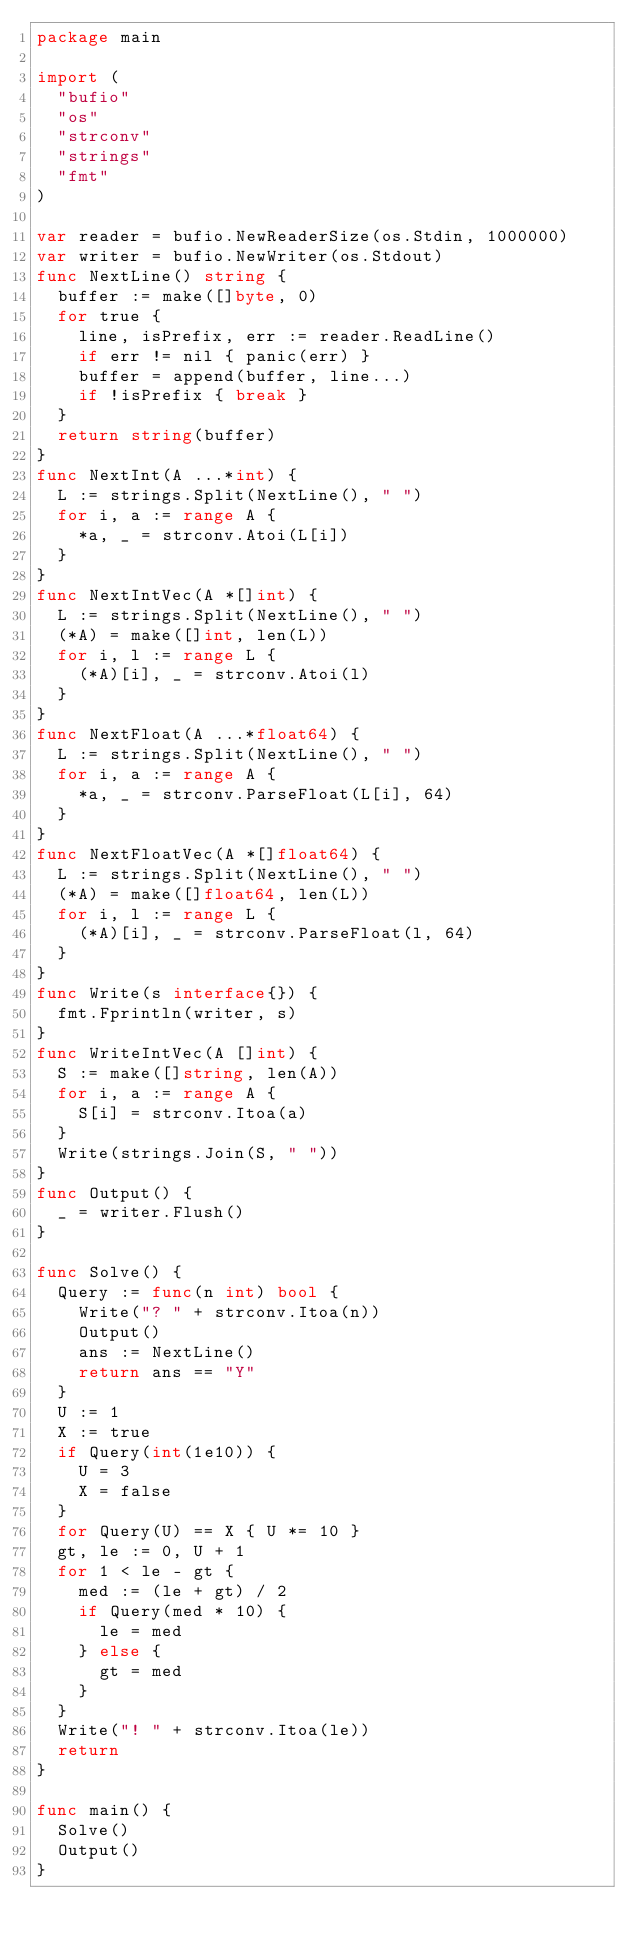<code> <loc_0><loc_0><loc_500><loc_500><_Go_>package main

import (
  "bufio"
  "os"
  "strconv"
  "strings"
  "fmt"
)

var reader = bufio.NewReaderSize(os.Stdin, 1000000)
var writer = bufio.NewWriter(os.Stdout)
func NextLine() string {
  buffer := make([]byte, 0)
  for true {
    line, isPrefix, err := reader.ReadLine()
    if err != nil { panic(err) }
    buffer = append(buffer, line...)
    if !isPrefix { break }
  }
  return string(buffer)
}
func NextInt(A ...*int) {
  L := strings.Split(NextLine(), " ")
  for i, a := range A {
    *a, _ = strconv.Atoi(L[i])
  }
}
func NextIntVec(A *[]int) {
  L := strings.Split(NextLine(), " ")
  (*A) = make([]int, len(L))
  for i, l := range L {
    (*A)[i], _ = strconv.Atoi(l)
  }
}
func NextFloat(A ...*float64) {
  L := strings.Split(NextLine(), " ")
  for i, a := range A {
    *a, _ = strconv.ParseFloat(L[i], 64)
  }
}
func NextFloatVec(A *[]float64) {
  L := strings.Split(NextLine(), " ")
  (*A) = make([]float64, len(L))
  for i, l := range L {
    (*A)[i], _ = strconv.ParseFloat(l, 64)
  }
}
func Write(s interface{}) {
  fmt.Fprintln(writer, s)
}
func WriteIntVec(A []int) {
  S := make([]string, len(A))
  for i, a := range A {
    S[i] = strconv.Itoa(a)
  }
  Write(strings.Join(S, " "))
}
func Output() {
  _ = writer.Flush()
}

func Solve() {
  Query := func(n int) bool {
    Write("? " + strconv.Itoa(n))
    Output()
    ans := NextLine()
    return ans == "Y"
  }
  U := 1
  X := true
  if Query(int(1e10)) {
    U = 3
    X = false
  }
  for Query(U) == X { U *= 10 }
  gt, le := 0, U + 1
  for 1 < le - gt {
    med := (le + gt) / 2
    if Query(med * 10) {
      le = med
    } else {
      gt = med
    }
  }
  Write("! " + strconv.Itoa(le))
  return
}

func main() {
  Solve()
  Output()
}</code> 